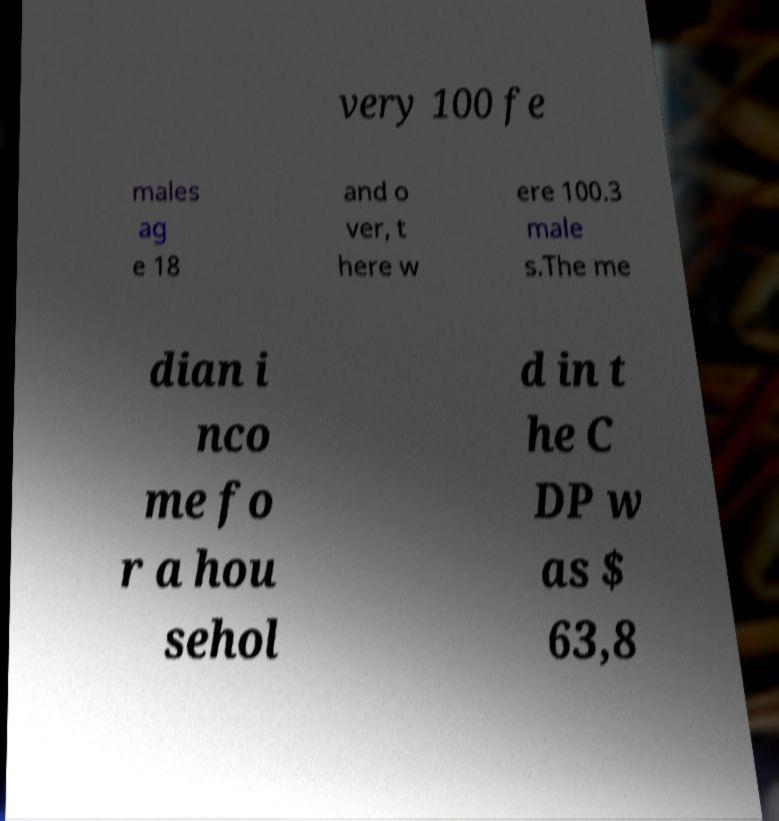Could you assist in decoding the text presented in this image and type it out clearly? very 100 fe males ag e 18 and o ver, t here w ere 100.3 male s.The me dian i nco me fo r a hou sehol d in t he C DP w as $ 63,8 